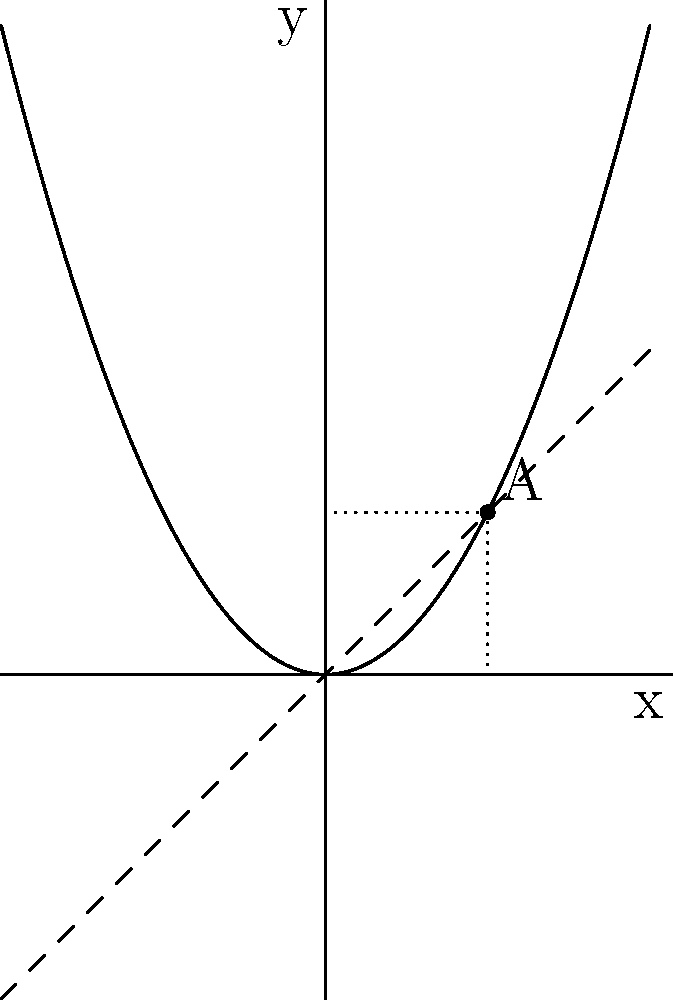Cheryl, remember our discussions about rates of change? Look at this parabola. Point A has coordinates (2, 2). What's the instantaneous rate of change of the function at this point? Let's approach this step-by-step, Cheryl:

1) The parabola represents a quadratic function. Its general form is $f(x) = ax^2 + bx + c$.

2) We can see that the parabola passes through the point (2, 2).

3) The instantaneous rate of change at a point is equal to the slope of the tangent line at that point.

4) For a quadratic function $f(x) = ax^2 + bx + c$, its derivative is $f'(x) = 2ax + b$.

5) The derivative gives us the instantaneous rate of change at any point.

6) We can see that at x = 2, the tangent line to the parabola appears to be the same as the line y = x (the dashed line).

7) The line y = x has a slope of 1.

Therefore, the instantaneous rate of change at point A (2, 2) is 1.
Answer: 1 